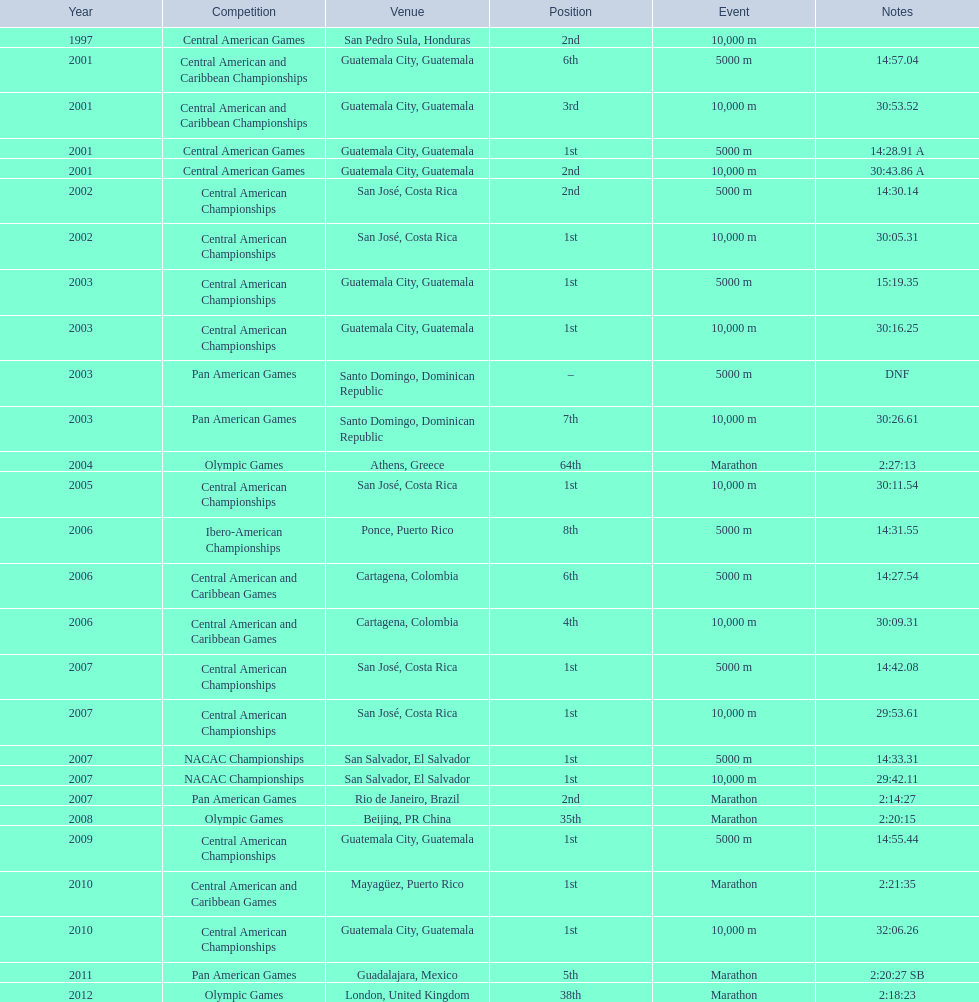In how many occurrences has the rank of 1st been reached? 12. 